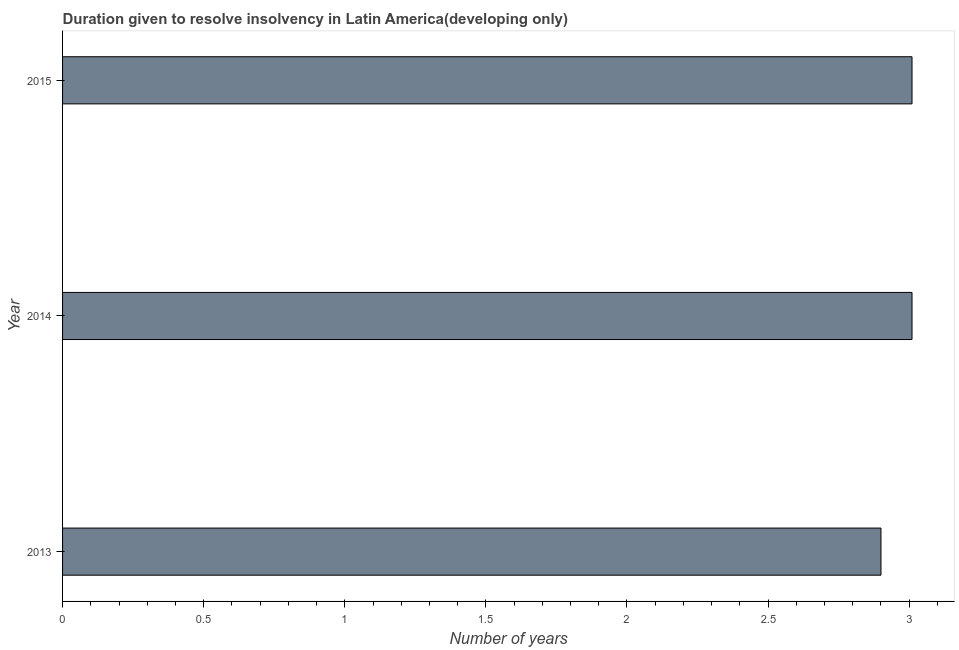What is the title of the graph?
Offer a very short reply. Duration given to resolve insolvency in Latin America(developing only). What is the label or title of the X-axis?
Offer a terse response. Number of years. What is the number of years to resolve insolvency in 2015?
Your answer should be compact. 3.01. Across all years, what is the maximum number of years to resolve insolvency?
Provide a succinct answer. 3.01. In which year was the number of years to resolve insolvency maximum?
Offer a very short reply. 2014. In which year was the number of years to resolve insolvency minimum?
Your answer should be very brief. 2013. What is the sum of the number of years to resolve insolvency?
Ensure brevity in your answer.  8.92. What is the average number of years to resolve insolvency per year?
Make the answer very short. 2.97. What is the median number of years to resolve insolvency?
Offer a terse response. 3.01. In how many years, is the number of years to resolve insolvency greater than 0.7 ?
Your response must be concise. 3. Do a majority of the years between 2015 and 2013 (inclusive) have number of years to resolve insolvency greater than 0.7 ?
Provide a succinct answer. Yes. What is the ratio of the number of years to resolve insolvency in 2014 to that in 2015?
Your answer should be very brief. 1. Is the number of years to resolve insolvency in 2014 less than that in 2015?
Keep it short and to the point. No. Is the difference between the number of years to resolve insolvency in 2013 and 2014 greater than the difference between any two years?
Offer a terse response. Yes. What is the difference between the highest and the second highest number of years to resolve insolvency?
Ensure brevity in your answer.  0. Is the sum of the number of years to resolve insolvency in 2013 and 2014 greater than the maximum number of years to resolve insolvency across all years?
Offer a very short reply. Yes. What is the difference between the highest and the lowest number of years to resolve insolvency?
Ensure brevity in your answer.  0.11. In how many years, is the number of years to resolve insolvency greater than the average number of years to resolve insolvency taken over all years?
Provide a short and direct response. 2. How many bars are there?
Offer a very short reply. 3. How many years are there in the graph?
Provide a short and direct response. 3. What is the difference between two consecutive major ticks on the X-axis?
Your answer should be compact. 0.5. What is the Number of years of 2014?
Keep it short and to the point. 3.01. What is the Number of years in 2015?
Offer a terse response. 3.01. What is the difference between the Number of years in 2013 and 2014?
Offer a very short reply. -0.11. What is the difference between the Number of years in 2013 and 2015?
Ensure brevity in your answer.  -0.11. What is the difference between the Number of years in 2014 and 2015?
Make the answer very short. 0. What is the ratio of the Number of years in 2013 to that in 2014?
Make the answer very short. 0.96. 